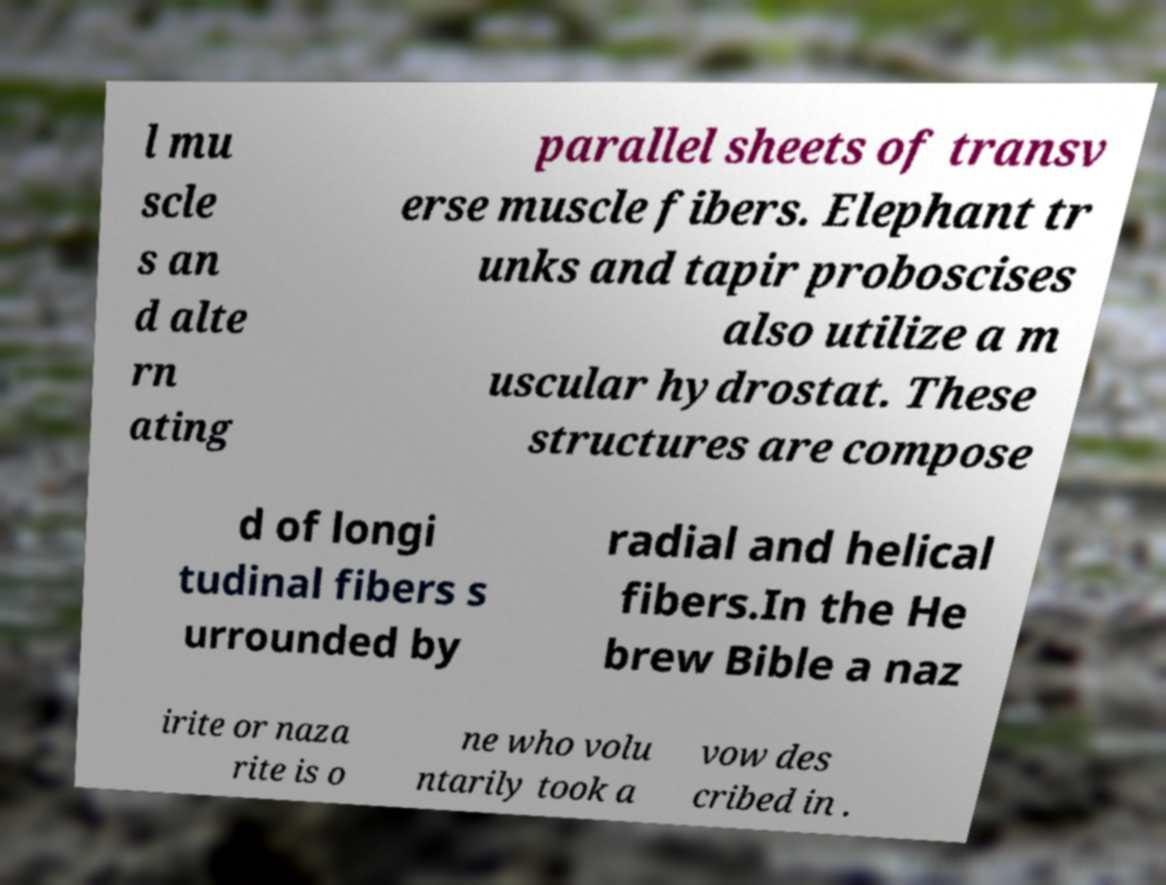Can you accurately transcribe the text from the provided image for me? l mu scle s an d alte rn ating parallel sheets of transv erse muscle fibers. Elephant tr unks and tapir proboscises also utilize a m uscular hydrostat. These structures are compose d of longi tudinal fibers s urrounded by radial and helical fibers.In the He brew Bible a naz irite or naza rite is o ne who volu ntarily took a vow des cribed in . 